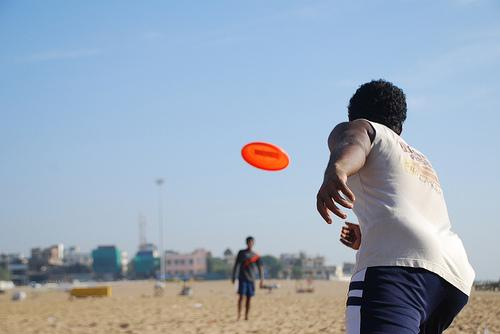Please provide a short description of the man's clothes. The man is wearing a grey shirt with a red strip and blue shorts with white markings. Is there any object with blue and white stripes in the image? Yes, there are blue and white stripes on the man's shorts. Can you describe the setting of the image in brief? The image is set on a sandy beach with several buildings in the distance. Briefly describe any object people are engaging with in the image. People are engaging with an orange frisbee being tossed in the air. What action is the man performing while waiting for the frisbee? The man is lunging in the sand and waiting to catch the frisbee. What is being thrown in the image? An orange frisbee is being thrown in the air. Summarize the activity happening in the image. A man is playing frisbee on a sandy beach, waiting to catch an orange frisbee thrown in the air. Mention any distinctive feature of the man in the image. The man has black hair and is leaning forward to catch the frisbee. Describe any structures or objects in the image that stand out. A pink building, a yellow box, and a white pole are visible in the distance. Tell me about the weather and the sky in the image. The sky is hazy with a blue tinge, suggesting a day at the beach. 